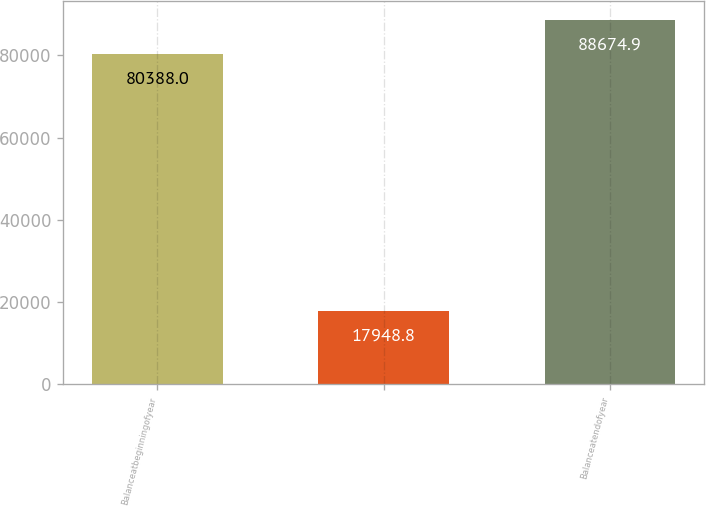Convert chart to OTSL. <chart><loc_0><loc_0><loc_500><loc_500><bar_chart><fcel>Balanceatbeginningofyear<fcel>Unnamed: 1<fcel>Balanceatendofyear<nl><fcel>80388<fcel>17948.8<fcel>88674.9<nl></chart> 